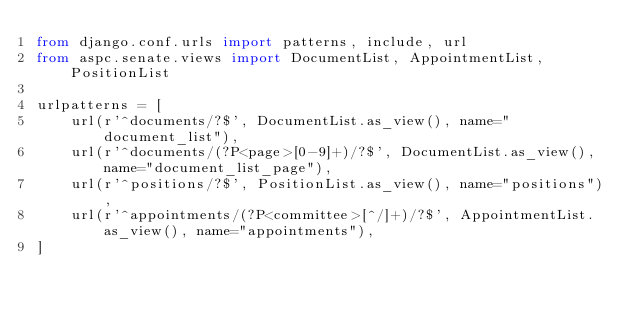Convert code to text. <code><loc_0><loc_0><loc_500><loc_500><_Python_>from django.conf.urls import patterns, include, url
from aspc.senate.views import DocumentList, AppointmentList, PositionList

urlpatterns = [
    url(r'^documents/?$', DocumentList.as_view(), name="document_list"),
    url(r'^documents/(?P<page>[0-9]+)/?$', DocumentList.as_view(), name="document_list_page"),
    url(r'^positions/?$', PositionList.as_view(), name="positions"),
    url(r'^appointments/(?P<committee>[^/]+)/?$', AppointmentList.as_view(), name="appointments"),
]</code> 